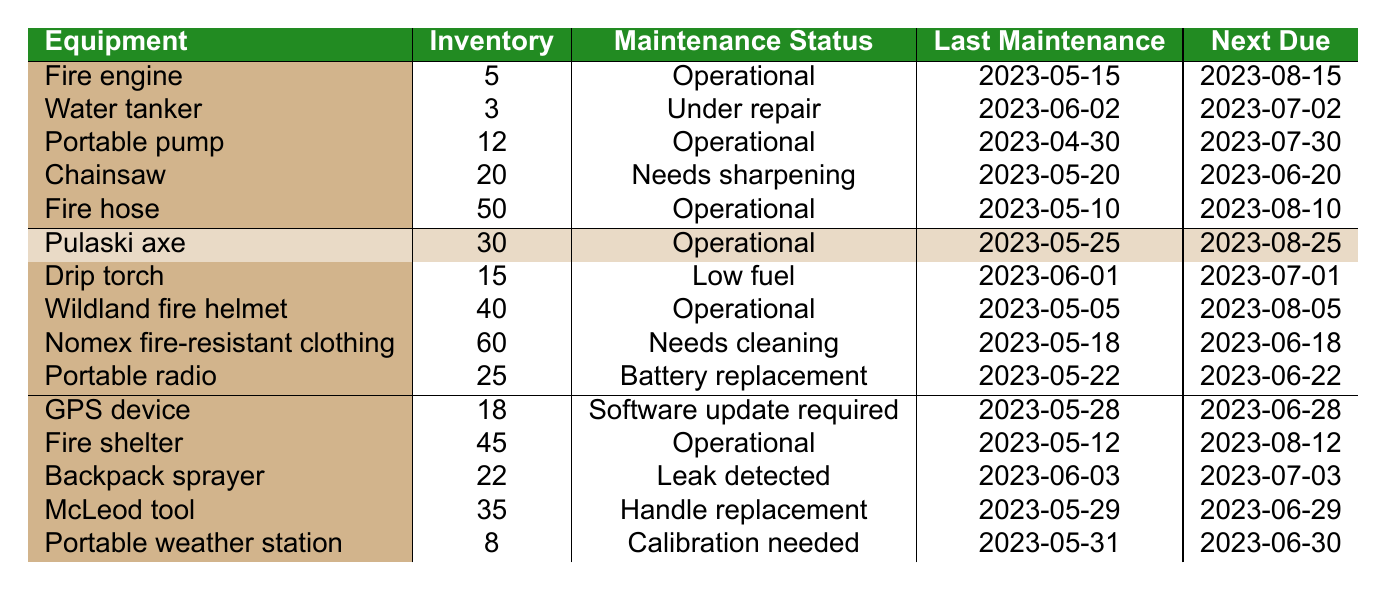What is the maintenance status of the water tanker? The maintenance status of the water tanker is listed in the table, and it shows "Under repair."
Answer: Under repair How many portable pumps are currently in inventory? Referring to the table, the inventory count for portable pumps is 12.
Answer: 12 Is the fire engine operational? According to the table, the fire engine's maintenance status is "Operational," which confirms it is functioning properly.
Answer: Yes What equipment requires calibration? The table shows that the "Portable weather station" requires calibration as per its maintenance status.
Answer: Portable weather station Which equipment has the highest inventory count? By examining the inventory counts in the table, the Nomex fire-resistant clothing has the highest count at 60.
Answer: Nomex fire-resistant clothing How many pieces of equipment have a maintenance status other than "Operational"? There are 6 pieces of equipment with a status other than "Operational" (Water tanker, Chainsaw, Drip torch, Nomex fire-resistant clothing, Portable radio, Backpack sprayer, McLeod tool, Portable weather station).
Answer: 8 What is the next maintenance due date for the portable radio? The table indicates that the next maintenance due date for the portable radio is 2023-06-22.
Answer: 2023-06-22 Which equipment was last maintained on 2023-05-31? According to the table, the equipment last maintained on that date is the Portable weather station.
Answer: Portable weather station How many pieces of equipment need maintenance before the end of June? Referring to the table, 6 pieces require maintenance before the end of June (Chainsaw, Nomex fire-resistant clothing, Portable radio, GPS device, McLeod tool, Portable weather station).
Answer: 6 What is the average inventory count of all the equipment? Summing the inventory counts (5 + 3 + 12 + 20 + 50 + 30 + 15 + 40 + 60 + 25 + 18 + 45 + 22 + 35 + 8) equals  363. With 15 pieces of equipment, the average is 363/15, which equals approximately 24.2.
Answer: 24.2 Which equipment has the next maintenance due date of 2023-07-01? The table shows that the Drip torch has the next maintenance due date of 2023-07-01.
Answer: Drip torch What proportion of the equipment is currently operational? From the table, 7 out of 15 pieces of equipment are operational, giving a proportion of 7/15 or approximately 0.47.
Answer: 0.47 Are there any pieces of equipment that are operational and require cleaning? The table shows that there is one piece of equipment, the Nomex fire-resistant clothing, which is operational but needs cleaning.
Answer: No What is the difference in inventory count between the fire hose and the portable weather station? The fire hose has an inventory count of 50, while the portable weather station has 8. The difference is 50 - 8 = 42.
Answer: 42 